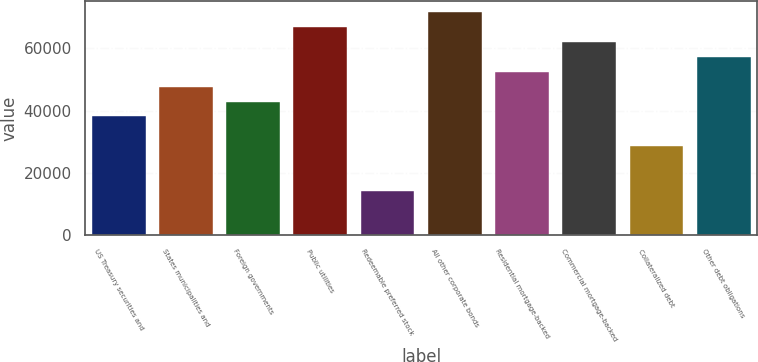<chart> <loc_0><loc_0><loc_500><loc_500><bar_chart><fcel>US Treasury securities and<fcel>States municipalities and<fcel>Foreign governments<fcel>Public utilities<fcel>Redeemable preferred stock<fcel>All other corporate bonds<fcel>Residential mortgage-backed<fcel>Commercial mortgage-backed<fcel>Collateralized debt<fcel>Other debt obligations<nl><fcel>38173.3<fcel>47715.3<fcel>42944.3<fcel>66799.4<fcel>14318.2<fcel>71570.4<fcel>52486.3<fcel>62028.4<fcel>28631.2<fcel>57257.3<nl></chart> 